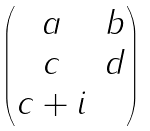Convert formula to latex. <formula><loc_0><loc_0><loc_500><loc_500>\begin{pmatrix} a & b \\ c & d \\ c + i & \end{pmatrix}</formula> 